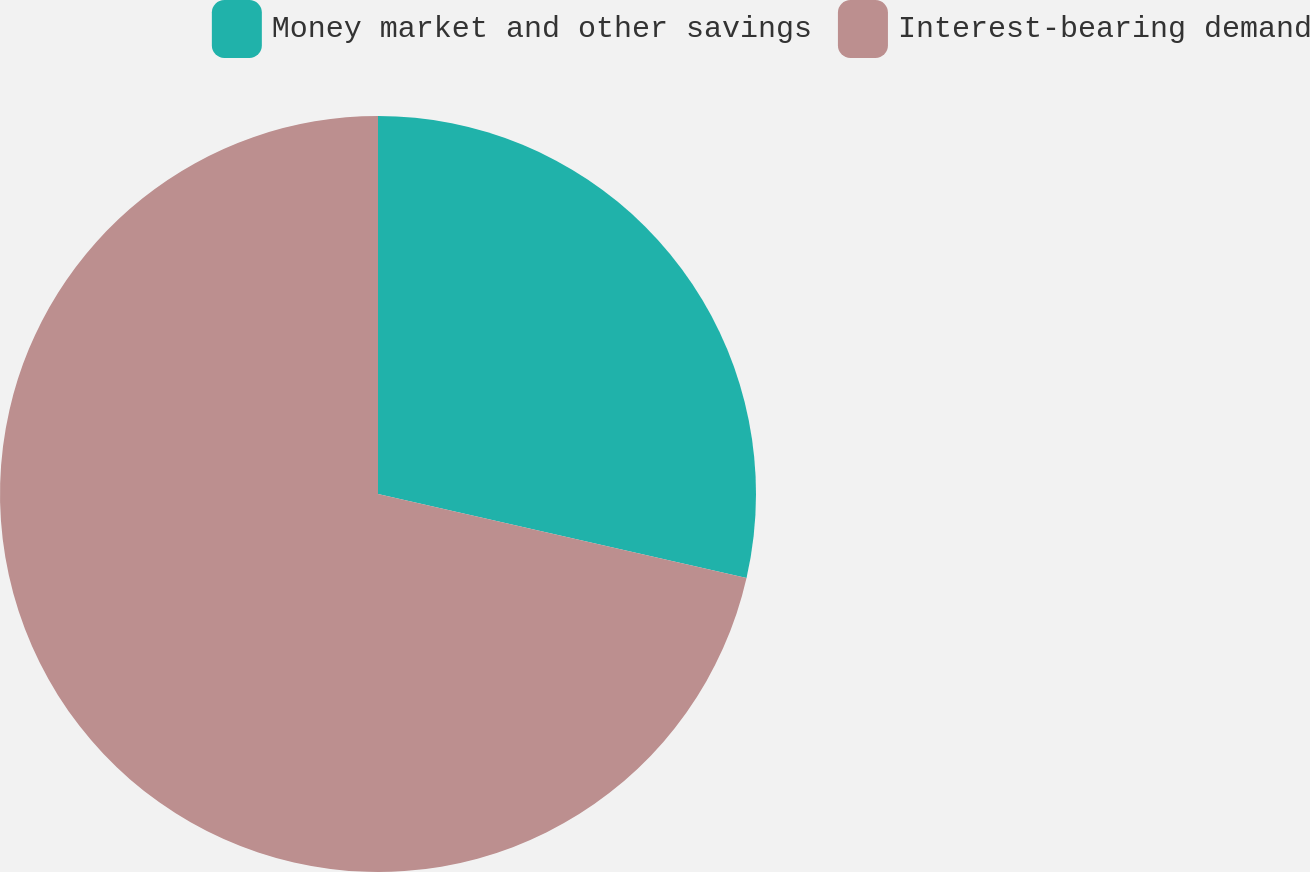Convert chart. <chart><loc_0><loc_0><loc_500><loc_500><pie_chart><fcel>Money market and other savings<fcel>Interest-bearing demand<nl><fcel>28.57%<fcel>71.43%<nl></chart> 